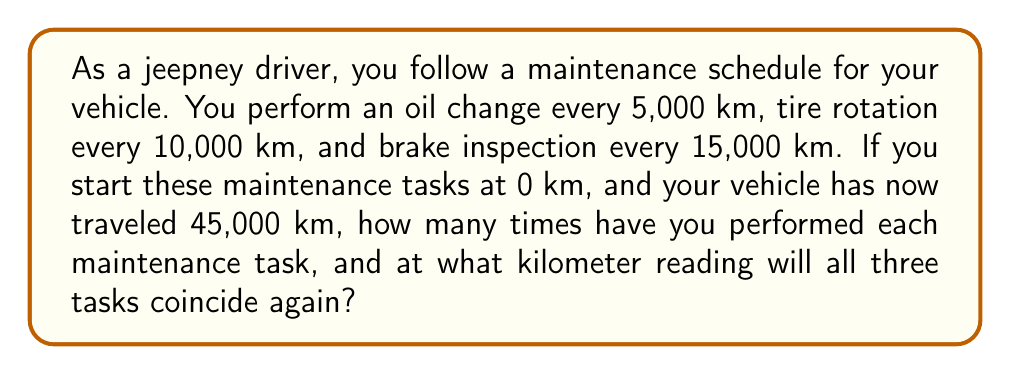Solve this math problem. Let's approach this step-by-step:

1. Calculate the number of times each task has been performed:

   Oil change: $\frac{45,000}{5,000} = 9$ times
   Tire rotation: $\frac{45,000}{10,000} = 4.5 \approx 4$ times
   Brake inspection: $\frac{45,000}{15,000} = 3$ times

2. To find when all tasks coincide, we need to find the least common multiple (LCM) of their intervals:

   $LCM(5000, 10000, 15000)$

3. First, prime factorize each number:
   $5000 = 2^3 \times 5^4$
   $10000 = 2^4 \times 5^4$
   $15000 = 2^3 \times 3 \times 5^4$

4. The LCM will include the highest power of each prime factor:
   $LCM = 2^4 \times 3 \times 5^4 = 30000$

5. Therefore, all tasks will coincide every 30,000 km.

6. The next time all tasks coincide after 45,000 km will be at:
   $45,000 + 30,000 = 75,000$ km
Answer: Oil change: 9 times, Tire rotation: 4 times, Brake inspection: 3 times. All tasks will coincide at 75,000 km. 